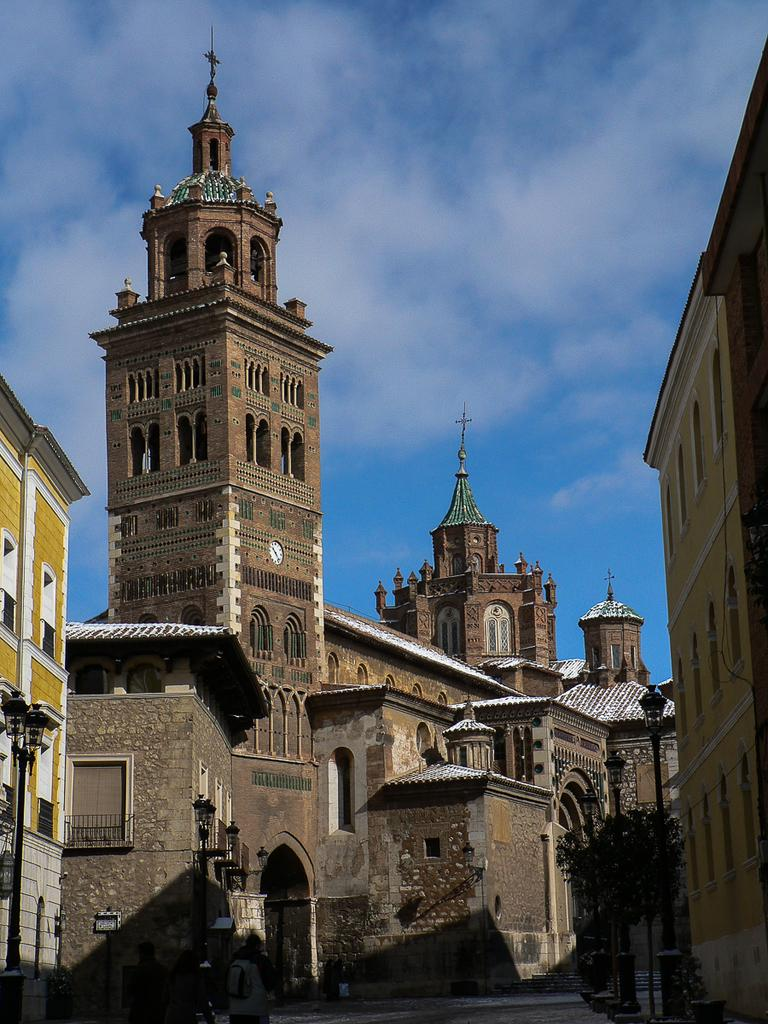What are the people in the image doing? The people in the image are walking on the road. What structures can be seen in the image? There are buildings in the image. What type of vegetation is present in the image? There are trees in the image. What type of lighting is present along the road? There are street lights in the image. What can be seen in the background of the image? The sky is visible in the background of the image. What type of skirt is the slave wearing in the image? There is no slave or skirt present in the image. 